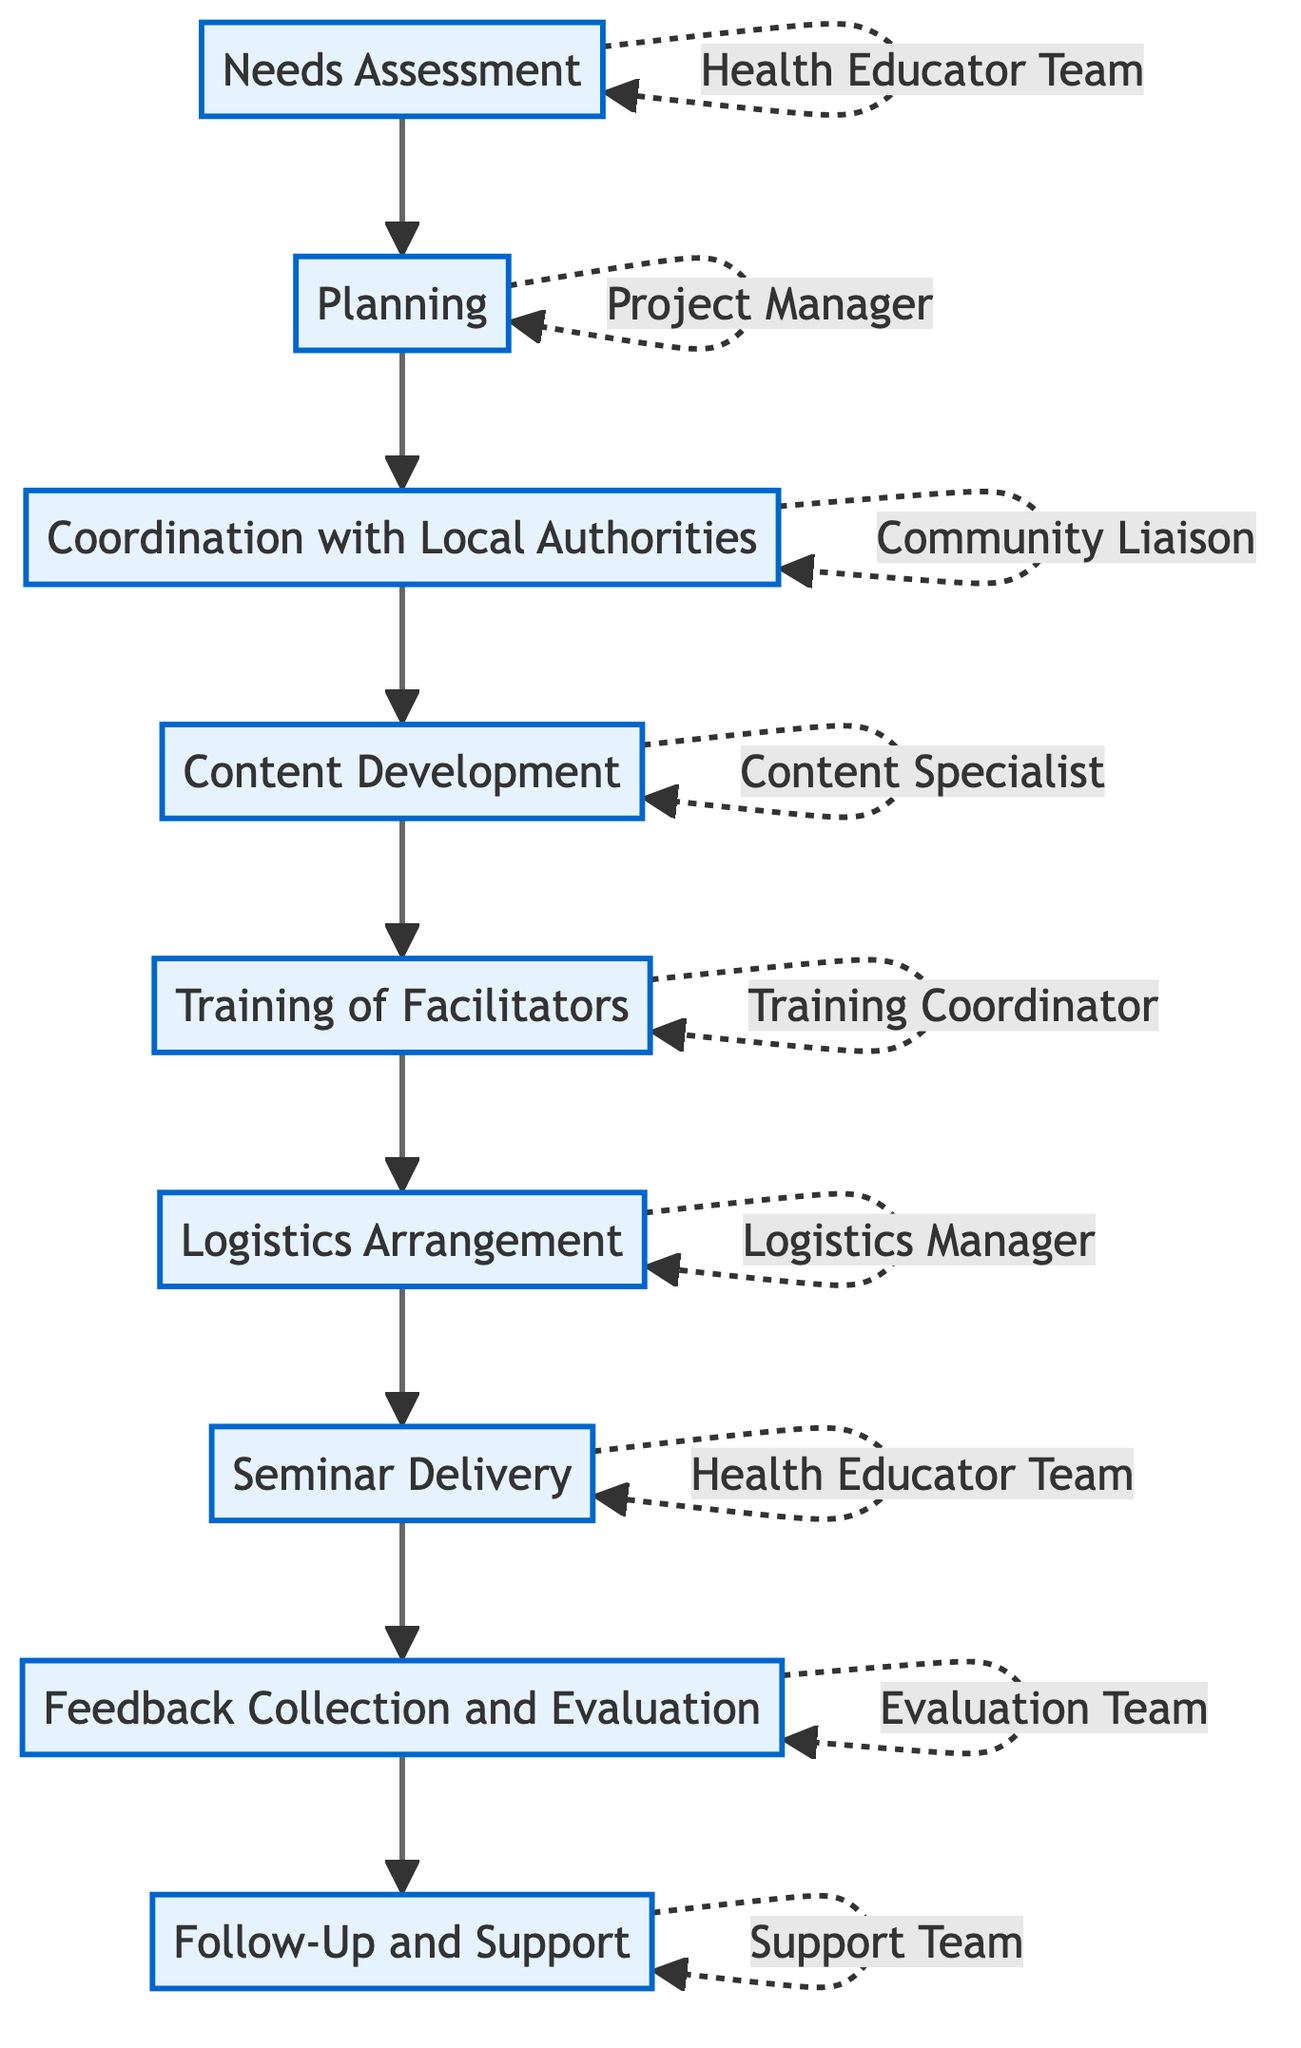What's the first step in the workflow? The diagram indicates that the first step in the workflow is "Needs Assessment," which is where the health education needs are identified.
Answer: Needs Assessment How many steps are in the workflow? By counting all the steps in the diagram, we see that there are a total of nine distinct steps listed in the workflow.
Answer: Nine Who is responsible for "Content Development"? The diagram specifies that the "Content Specialist" is responsible for the "Content Development" step in the workflow.
Answer: Content Specialist What is the last step mentioned in the workflow? The flowchart shows that the last step in the workflow is "Follow-Up and Support," which ensures ongoing assistance to the community.
Answer: Follow-Up and Support What step comes after "Planning"? According to the flow of the diagram, the step that follows "Planning" is "Coordination with Local Authorities."
Answer: Coordination with Local Authorities Which responsible entity is associated with "Logistics Arrangement"? The flowchart indicates that the "Logistics Manager" is the responsible entity for the "Logistics Arrangement" step in the workflow.
Answer: Logistics Manager How many entities are identified as responsible for delivering the seminar? In the diagram, the "Health Educator Team" is noted as responsible for two steps: "Needs Assessment" and "Seminar Delivery," confirming there is one entity responsible for delivering the seminar.
Answer: One What type of method is used in the "Seminar Delivery" step? The diagram suggests that "interactive and engaging methods" are employed during the "Seminar Delivery."
Answer: Interactive and engaging methods Which step evaluates the effectiveness of the seminar? The "Feedback Collection and Evaluation" step is identified in the diagram as the one that gathers feedback and evaluates the effectiveness of the seminar.
Answer: Feedback Collection and Evaluation 